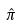Convert formula to latex. <formula><loc_0><loc_0><loc_500><loc_500>\hat { \pi }</formula> 